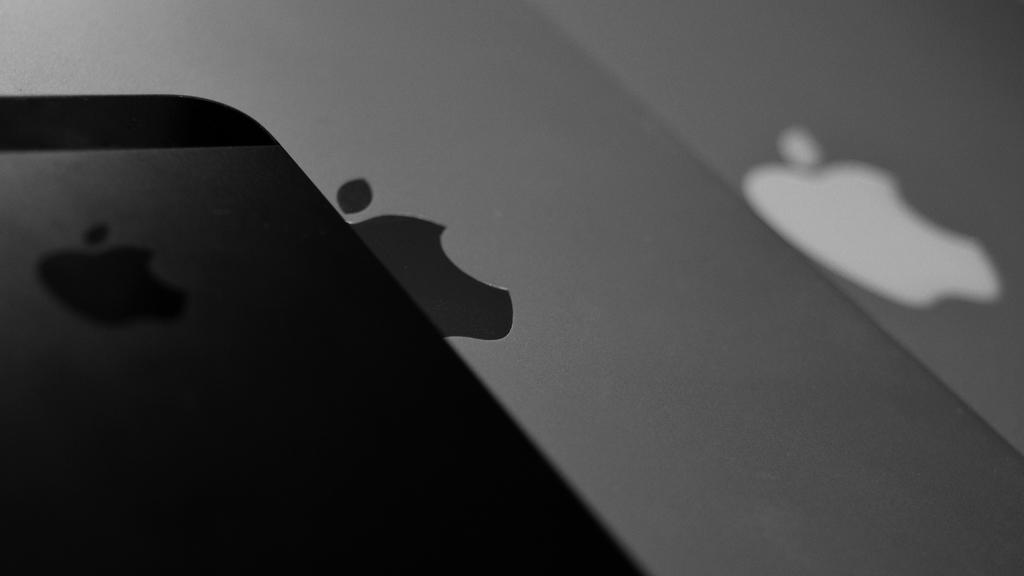What type of device is shown in the image? The image shows the backside view of an Apple phone. What color is the background in the image? There is a grey background in the image. What symbol or logo is visible on the device? The Apple logo is visible in the image. What type of map is visible on the back of the Apple phone in the image? There is no map visible on the back of the Apple phone in the image; only the Apple logo is present. 